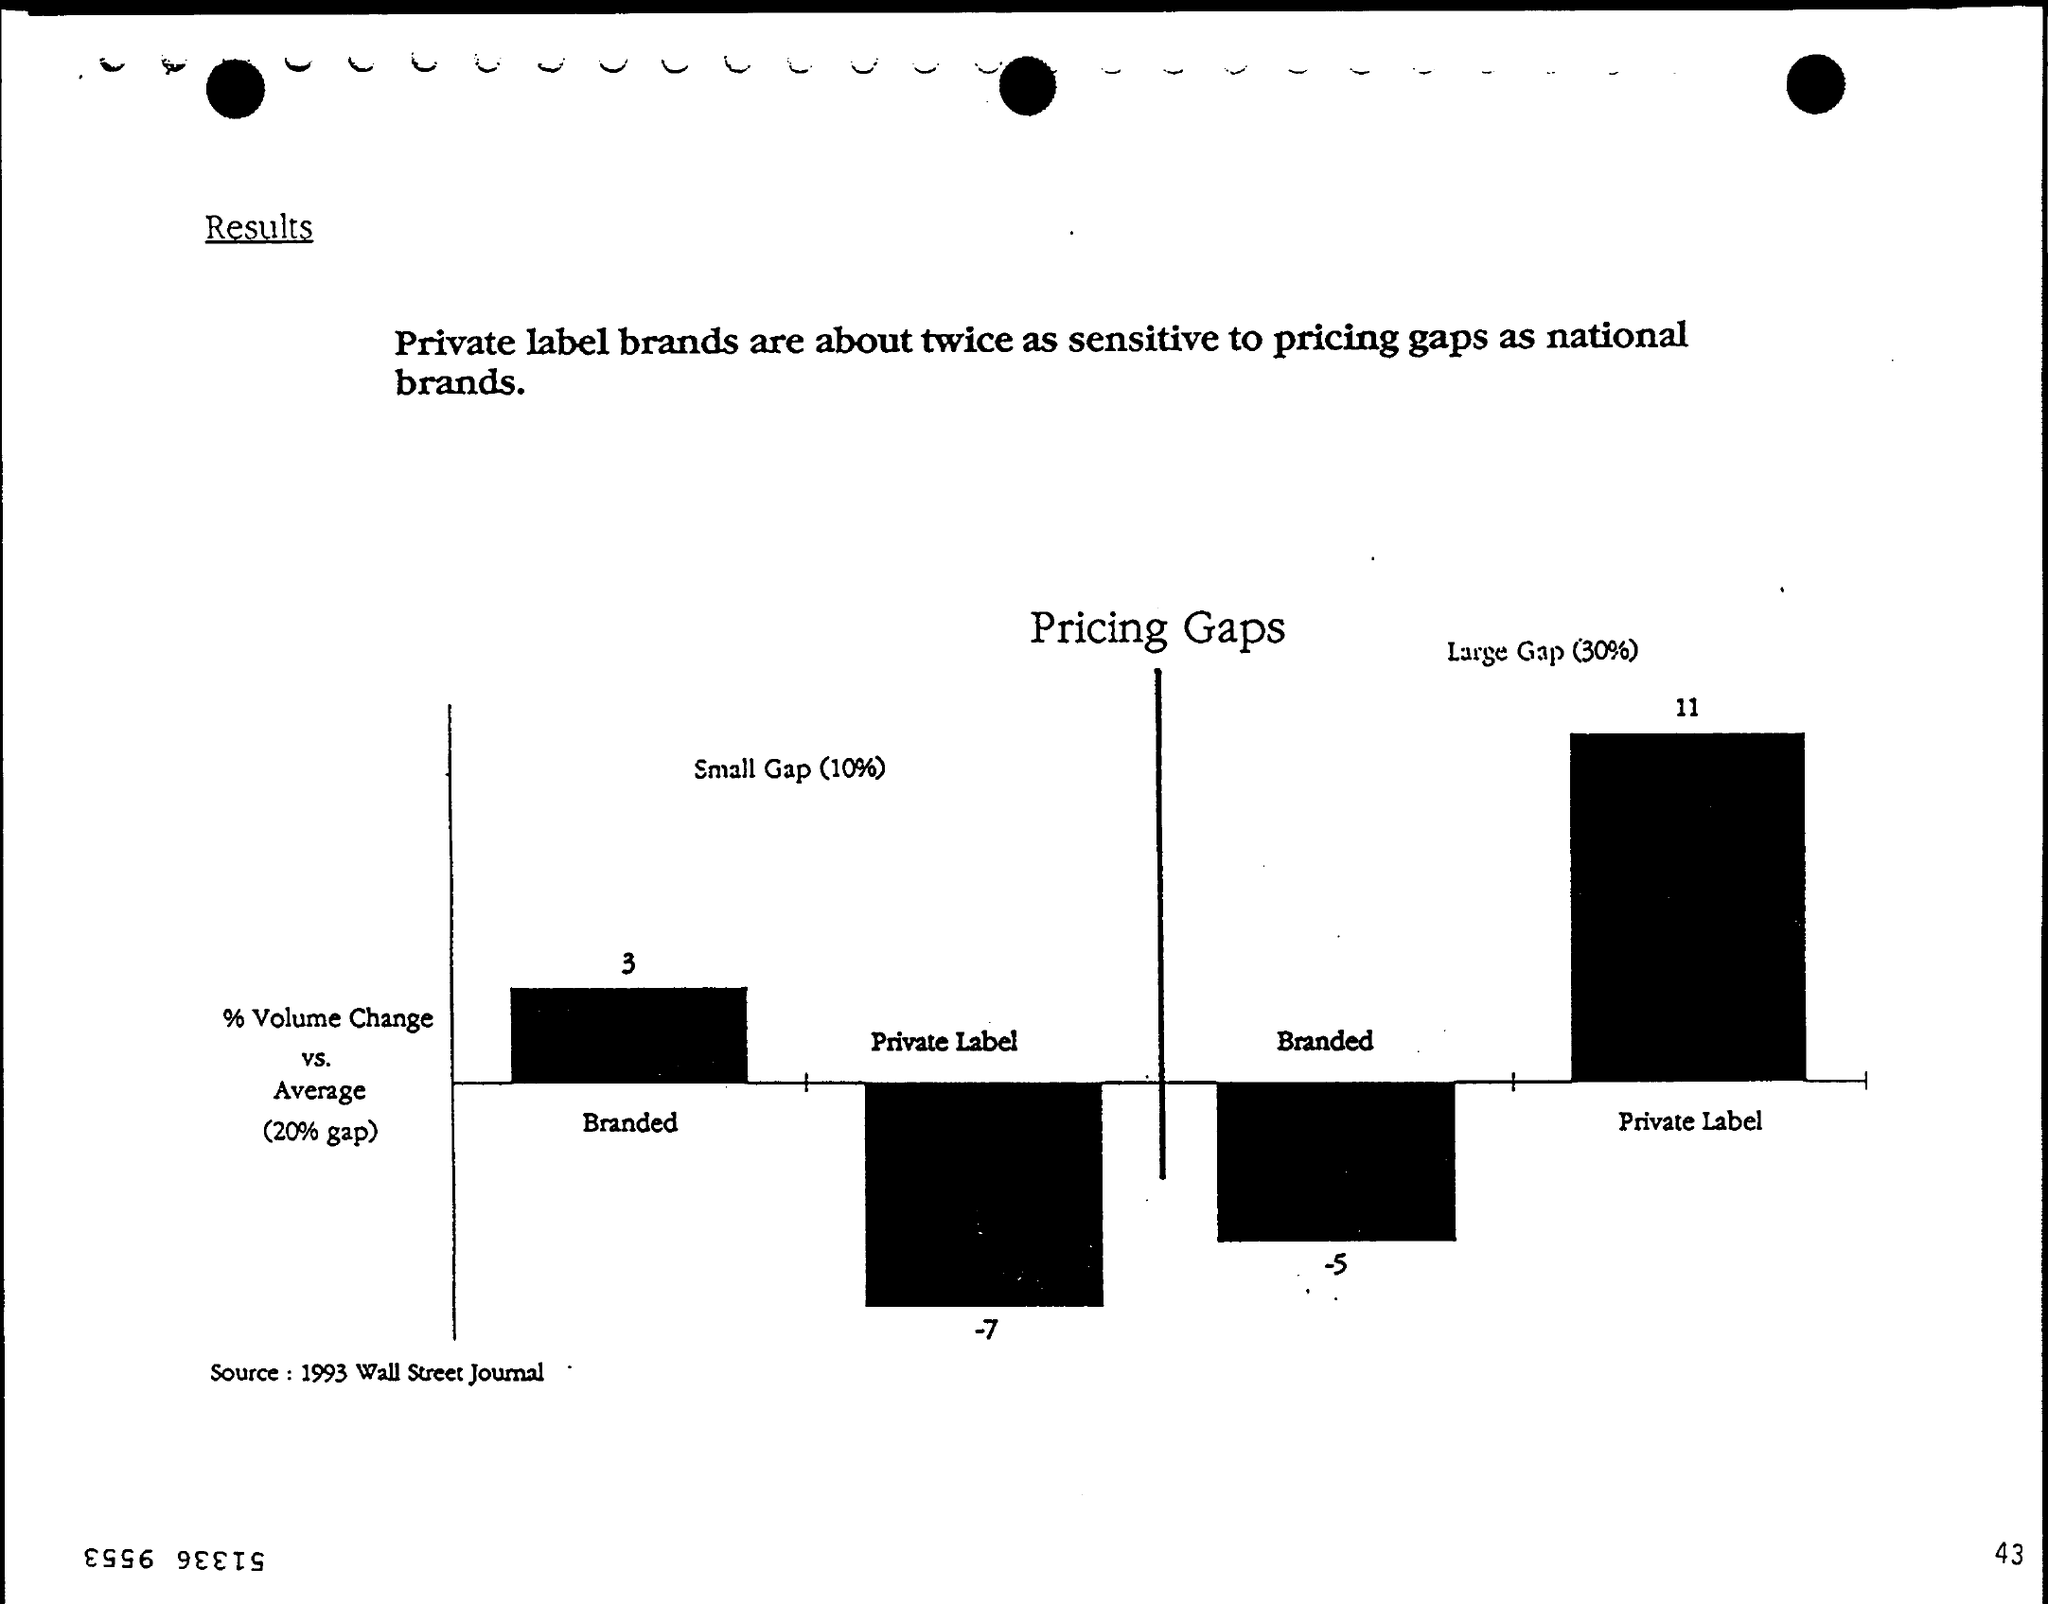Give some essential details in this illustration. The document's page number is 43. The source mentioned at the bottom of the page is the 1993 WALL STREET JOURNAL. 